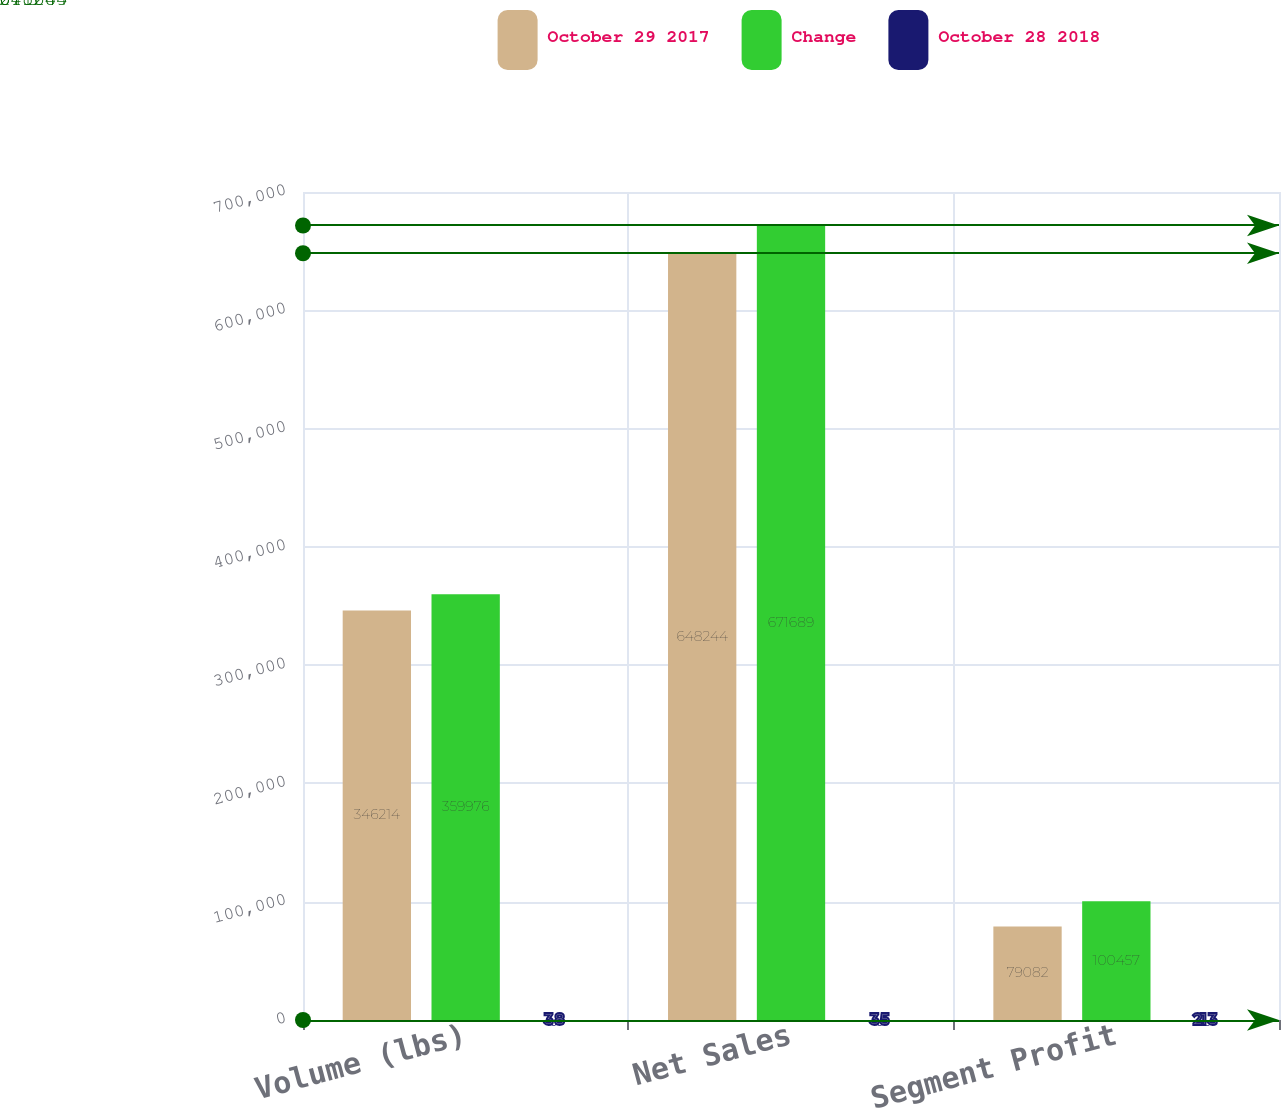<chart> <loc_0><loc_0><loc_500><loc_500><stacked_bar_chart><ecel><fcel>Volume (lbs)<fcel>Net Sales<fcel>Segment Profit<nl><fcel>October 29 2017<fcel>346214<fcel>648244<fcel>79082<nl><fcel>Change<fcel>359976<fcel>671689<fcel>100457<nl><fcel>October 28 2018<fcel>3.8<fcel>3.5<fcel>21.3<nl></chart> 